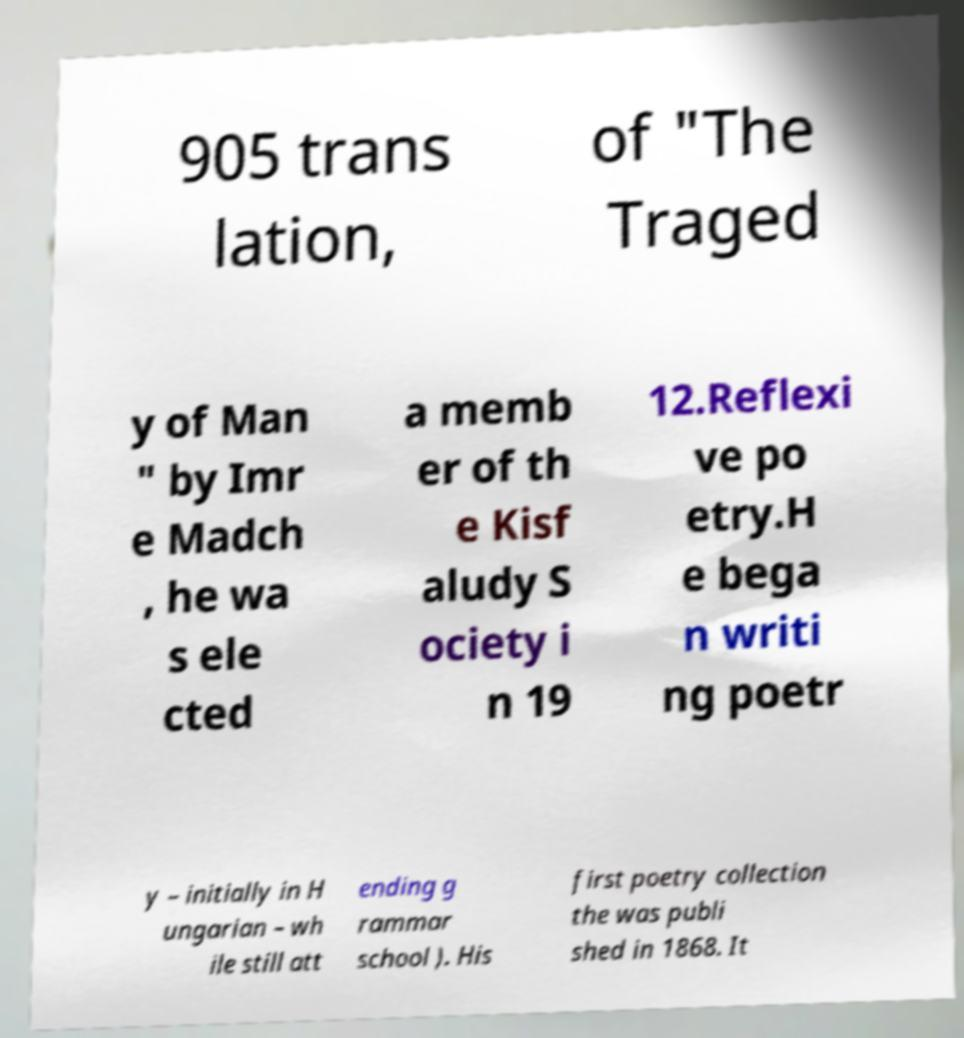What messages or text are displayed in this image? I need them in a readable, typed format. 905 trans lation, of "The Traged y of Man " by Imr e Madch , he wa s ele cted a memb er of th e Kisf aludy S ociety i n 19 12.Reflexi ve po etry.H e bega n writi ng poetr y – initially in H ungarian – wh ile still att ending g rammar school ). His first poetry collection the was publi shed in 1868. It 